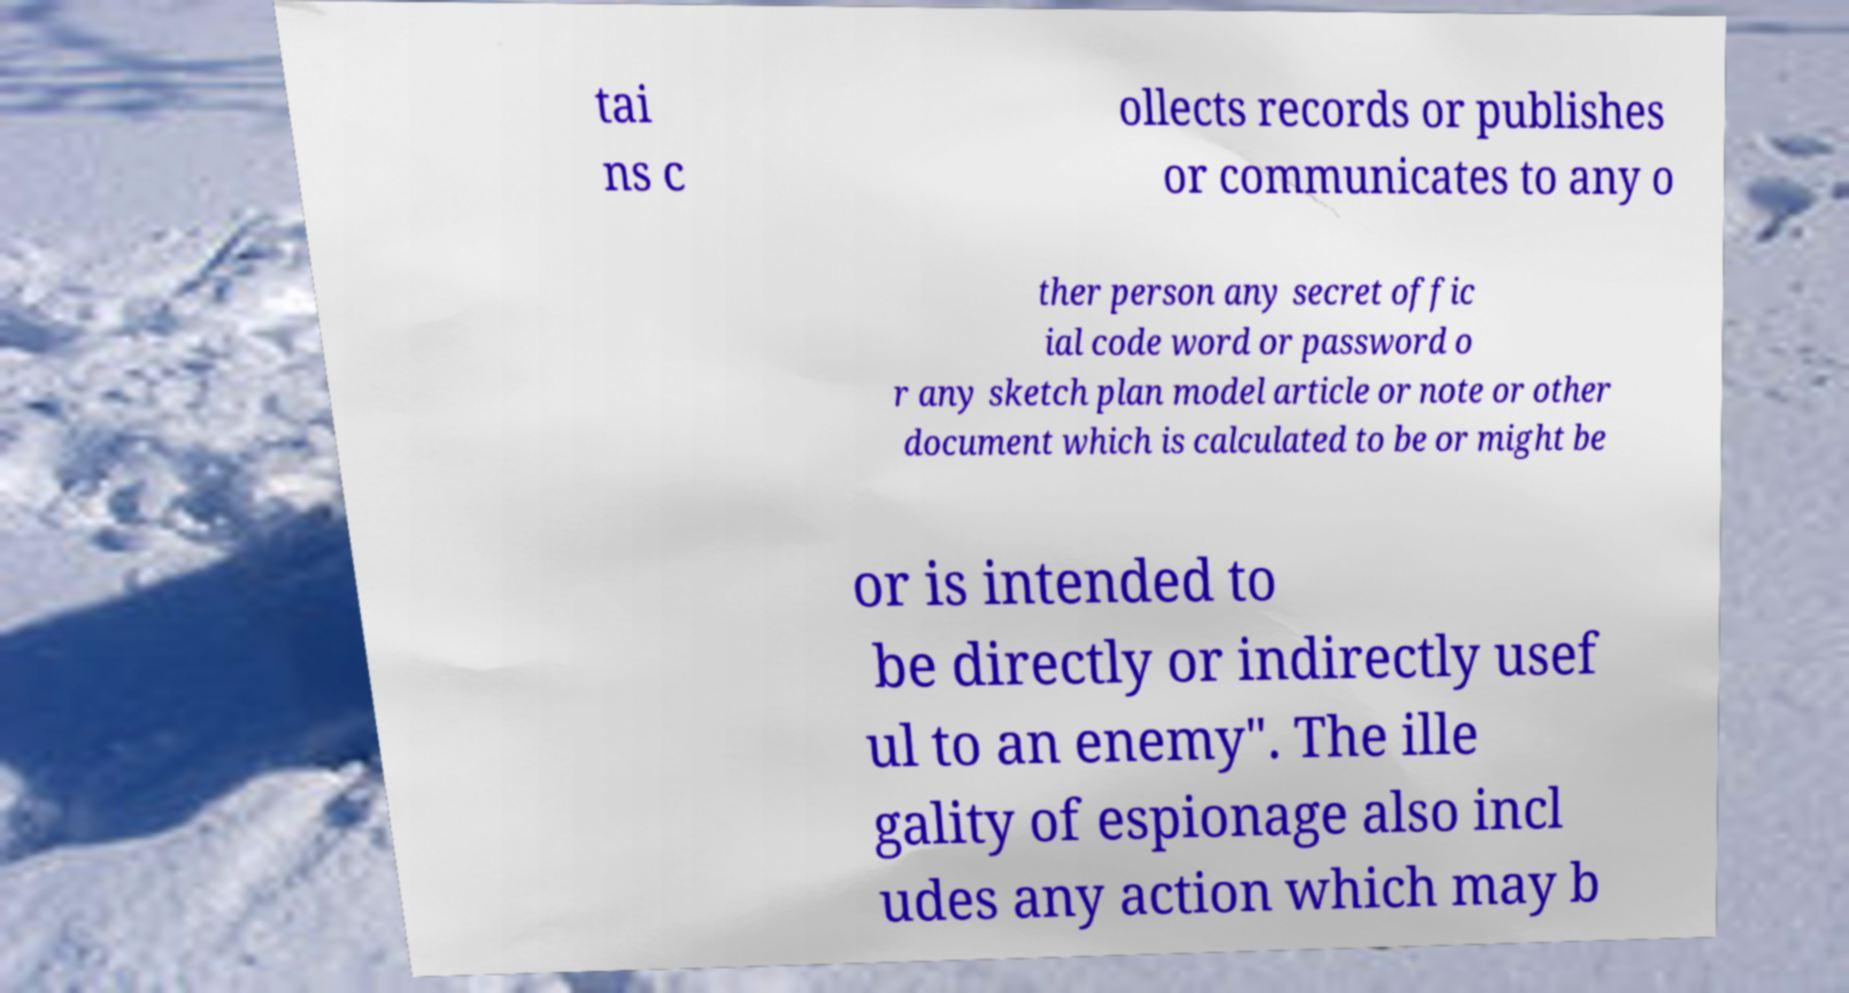There's text embedded in this image that I need extracted. Can you transcribe it verbatim? tai ns c ollects records or publishes or communicates to any o ther person any secret offic ial code word or password o r any sketch plan model article or note or other document which is calculated to be or might be or is intended to be directly or indirectly usef ul to an enemy". The ille gality of espionage also incl udes any action which may b 